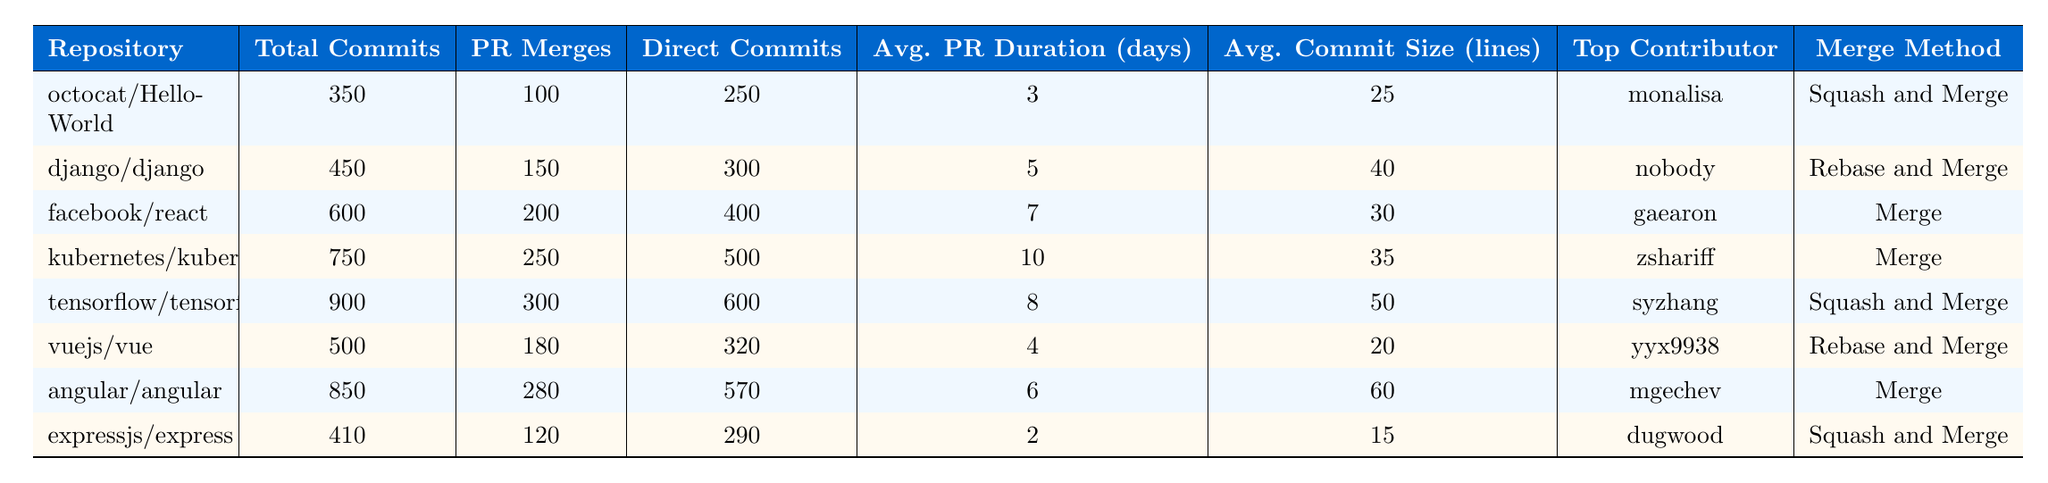What is the total number of commits in the kubernetes/kubernetes repository? The table shows that the total commits for the kubernetes/kubernetes repository are listed in the second column. Referring to that row, the total commits are 750.
Answer: 750 Which repository has the highest number of pull request merges? By reviewing the pull request merges column, the repository with the maximum pull request merges is tensorflow/tensorflow with 300 merges.
Answer: tensorflow/tensorflow What is the average pull request duration (in days) for the angular/angular repository? The average pull request duration can be found in the corresponding row under the column "Avg. PR Duration (days)", which indicates 6 days for the angular/angular repository.
Answer: 6 What is the average commit size (in lines) for the facebook/react repository? Looking at the "Avg. Commit Size (lines)" column for the facebook/react repository, the value is 30 lines.
Answer: 30 How many more direct commits does the tensorflow/tensorflow repository have compared to the octocat/Hello-World repository? For tensorflow/tensorflow, direct commits are 600, and for octocat/Hello-World, they are 250. The difference is 600 - 250 = 350.
Answer: 350 Is the top contributor to the django/django repository the same as the top contributor to the expressjs/express repository? The top contributor for django/django is listed as "nobody," while for expressjs/express, it is "dugwood." They are different, so the answer is no.
Answer: No What is the total number of pull request merges across all the repositories listed? To find this, I add up the pull request merges from all repositories: 100 + 150 + 200 + 250 + 300 + 180 + 280 + 120 = 1580.
Answer: 1580 What percentage of the total commits in the vuejs/vue repository are made up of pull request merges? The total commits for vuejs/vue are 500, and the pull request merges are 180. The percentage is calculated as (180/500) * 100 = 36%.
Answer: 36% Which repository has the longest average pull request duration and how long is it? By reviewing the "Avg. PR Duration (days)" column, the repository with the longest duration is kubernetes/kubernetes with 10 days.
Answer: kubernetes/kubernetes, 10 days Which merge method is used by the most repositories listed in the table? By counting the merge methods: 3 use "Merge," 3 use "Squash and Merge," and 2 use "Rebase and Merge." Therefore, "Merge" is used by the most repositories.
Answer: Merge 